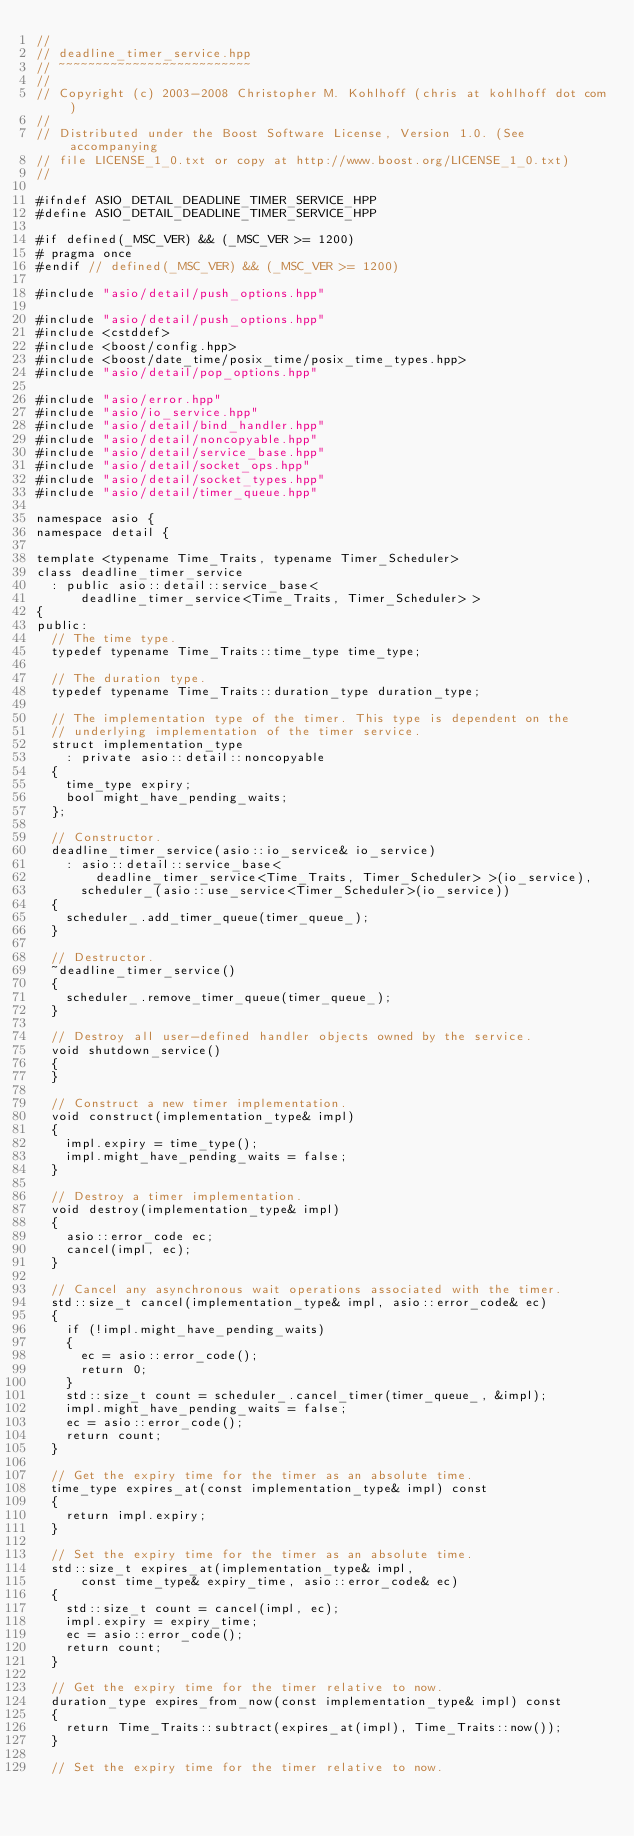<code> <loc_0><loc_0><loc_500><loc_500><_C++_>//
// deadline_timer_service.hpp
// ~~~~~~~~~~~~~~~~~~~~~~~~~~
//
// Copyright (c) 2003-2008 Christopher M. Kohlhoff (chris at kohlhoff dot com)
//
// Distributed under the Boost Software License, Version 1.0. (See accompanying
// file LICENSE_1_0.txt or copy at http://www.boost.org/LICENSE_1_0.txt)
//

#ifndef ASIO_DETAIL_DEADLINE_TIMER_SERVICE_HPP
#define ASIO_DETAIL_DEADLINE_TIMER_SERVICE_HPP

#if defined(_MSC_VER) && (_MSC_VER >= 1200)
# pragma once
#endif // defined(_MSC_VER) && (_MSC_VER >= 1200)

#include "asio/detail/push_options.hpp"

#include "asio/detail/push_options.hpp"
#include <cstddef>
#include <boost/config.hpp>
#include <boost/date_time/posix_time/posix_time_types.hpp>
#include "asio/detail/pop_options.hpp"

#include "asio/error.hpp"
#include "asio/io_service.hpp"
#include "asio/detail/bind_handler.hpp"
#include "asio/detail/noncopyable.hpp"
#include "asio/detail/service_base.hpp"
#include "asio/detail/socket_ops.hpp"
#include "asio/detail/socket_types.hpp"
#include "asio/detail/timer_queue.hpp"

namespace asio {
namespace detail {

template <typename Time_Traits, typename Timer_Scheduler>
class deadline_timer_service
  : public asio::detail::service_base<
      deadline_timer_service<Time_Traits, Timer_Scheduler> >
{
public:
  // The time type.
  typedef typename Time_Traits::time_type time_type;

  // The duration type.
  typedef typename Time_Traits::duration_type duration_type;

  // The implementation type of the timer. This type is dependent on the
  // underlying implementation of the timer service.
  struct implementation_type
    : private asio::detail::noncopyable
  {
    time_type expiry;
    bool might_have_pending_waits;
  };

  // Constructor.
  deadline_timer_service(asio::io_service& io_service)
    : asio::detail::service_base<
        deadline_timer_service<Time_Traits, Timer_Scheduler> >(io_service),
      scheduler_(asio::use_service<Timer_Scheduler>(io_service))
  {
    scheduler_.add_timer_queue(timer_queue_);
  }

  // Destructor.
  ~deadline_timer_service()
  {
    scheduler_.remove_timer_queue(timer_queue_);
  }

  // Destroy all user-defined handler objects owned by the service.
  void shutdown_service()
  {
  }

  // Construct a new timer implementation.
  void construct(implementation_type& impl)
  {
    impl.expiry = time_type();
    impl.might_have_pending_waits = false;
  }

  // Destroy a timer implementation.
  void destroy(implementation_type& impl)
  {
    asio::error_code ec;
    cancel(impl, ec);
  }

  // Cancel any asynchronous wait operations associated with the timer.
  std::size_t cancel(implementation_type& impl, asio::error_code& ec)
  {
    if (!impl.might_have_pending_waits)
    {
      ec = asio::error_code();
      return 0;
    }
    std::size_t count = scheduler_.cancel_timer(timer_queue_, &impl);
    impl.might_have_pending_waits = false;
    ec = asio::error_code();
    return count;
  }

  // Get the expiry time for the timer as an absolute time.
  time_type expires_at(const implementation_type& impl) const
  {
    return impl.expiry;
  }

  // Set the expiry time for the timer as an absolute time.
  std::size_t expires_at(implementation_type& impl,
      const time_type& expiry_time, asio::error_code& ec)
  {
    std::size_t count = cancel(impl, ec);
    impl.expiry = expiry_time;
    ec = asio::error_code();
    return count;
  }

  // Get the expiry time for the timer relative to now.
  duration_type expires_from_now(const implementation_type& impl) const
  {
    return Time_Traits::subtract(expires_at(impl), Time_Traits::now());
  }

  // Set the expiry time for the timer relative to now.</code> 